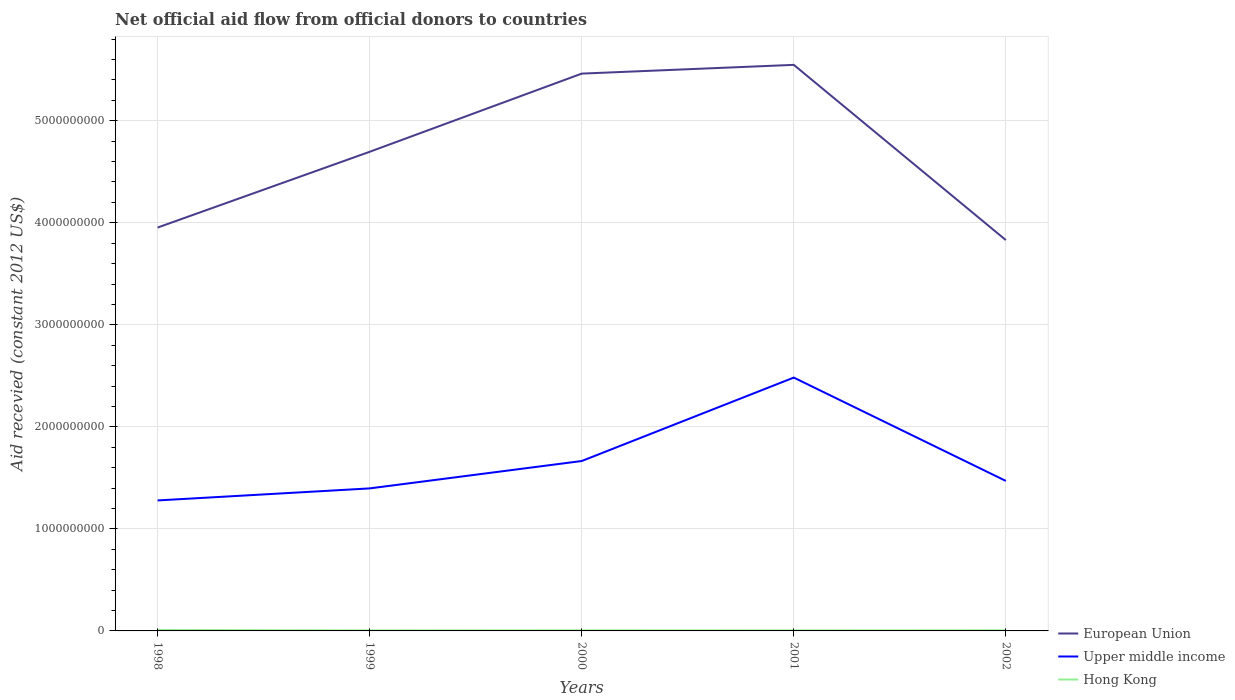Across all years, what is the maximum total aid received in Hong Kong?
Offer a terse response. 4.73e+06. What is the total total aid received in European Union in the graph?
Give a very brief answer. 1.23e+08. What is the difference between the highest and the second highest total aid received in European Union?
Provide a short and direct response. 1.72e+09. What is the difference between the highest and the lowest total aid received in Upper middle income?
Your response must be concise. 2. How many years are there in the graph?
Give a very brief answer. 5. What is the difference between two consecutive major ticks on the Y-axis?
Provide a short and direct response. 1.00e+09. Does the graph contain grids?
Your answer should be very brief. Yes. What is the title of the graph?
Keep it short and to the point. Net official aid flow from official donors to countries. What is the label or title of the X-axis?
Your answer should be compact. Years. What is the label or title of the Y-axis?
Ensure brevity in your answer.  Aid recevied (constant 2012 US$). What is the Aid recevied (constant 2012 US$) in European Union in 1998?
Provide a succinct answer. 3.95e+09. What is the Aid recevied (constant 2012 US$) in Upper middle income in 1998?
Provide a short and direct response. 1.28e+09. What is the Aid recevied (constant 2012 US$) in Hong Kong in 1998?
Provide a short and direct response. 9.64e+06. What is the Aid recevied (constant 2012 US$) of European Union in 1999?
Ensure brevity in your answer.  4.70e+09. What is the Aid recevied (constant 2012 US$) of Upper middle income in 1999?
Keep it short and to the point. 1.40e+09. What is the Aid recevied (constant 2012 US$) in Hong Kong in 1999?
Your answer should be very brief. 4.73e+06. What is the Aid recevied (constant 2012 US$) in European Union in 2000?
Ensure brevity in your answer.  5.46e+09. What is the Aid recevied (constant 2012 US$) of Upper middle income in 2000?
Your response must be concise. 1.67e+09. What is the Aid recevied (constant 2012 US$) in Hong Kong in 2000?
Offer a very short reply. 5.83e+06. What is the Aid recevied (constant 2012 US$) in European Union in 2001?
Make the answer very short. 5.55e+09. What is the Aid recevied (constant 2012 US$) in Upper middle income in 2001?
Ensure brevity in your answer.  2.48e+09. What is the Aid recevied (constant 2012 US$) in Hong Kong in 2001?
Give a very brief answer. 5.12e+06. What is the Aid recevied (constant 2012 US$) in European Union in 2002?
Provide a succinct answer. 3.83e+09. What is the Aid recevied (constant 2012 US$) in Upper middle income in 2002?
Your answer should be very brief. 1.47e+09. What is the Aid recevied (constant 2012 US$) of Hong Kong in 2002?
Provide a succinct answer. 5.92e+06. Across all years, what is the maximum Aid recevied (constant 2012 US$) of European Union?
Provide a succinct answer. 5.55e+09. Across all years, what is the maximum Aid recevied (constant 2012 US$) in Upper middle income?
Offer a very short reply. 2.48e+09. Across all years, what is the maximum Aid recevied (constant 2012 US$) in Hong Kong?
Keep it short and to the point. 9.64e+06. Across all years, what is the minimum Aid recevied (constant 2012 US$) of European Union?
Your answer should be very brief. 3.83e+09. Across all years, what is the minimum Aid recevied (constant 2012 US$) in Upper middle income?
Your answer should be very brief. 1.28e+09. Across all years, what is the minimum Aid recevied (constant 2012 US$) of Hong Kong?
Keep it short and to the point. 4.73e+06. What is the total Aid recevied (constant 2012 US$) in European Union in the graph?
Your answer should be compact. 2.35e+1. What is the total Aid recevied (constant 2012 US$) of Upper middle income in the graph?
Provide a short and direct response. 8.29e+09. What is the total Aid recevied (constant 2012 US$) of Hong Kong in the graph?
Offer a terse response. 3.12e+07. What is the difference between the Aid recevied (constant 2012 US$) of European Union in 1998 and that in 1999?
Your response must be concise. -7.42e+08. What is the difference between the Aid recevied (constant 2012 US$) in Upper middle income in 1998 and that in 1999?
Your response must be concise. -1.18e+08. What is the difference between the Aid recevied (constant 2012 US$) of Hong Kong in 1998 and that in 1999?
Offer a terse response. 4.91e+06. What is the difference between the Aid recevied (constant 2012 US$) in European Union in 1998 and that in 2000?
Ensure brevity in your answer.  -1.51e+09. What is the difference between the Aid recevied (constant 2012 US$) in Upper middle income in 1998 and that in 2000?
Ensure brevity in your answer.  -3.86e+08. What is the difference between the Aid recevied (constant 2012 US$) of Hong Kong in 1998 and that in 2000?
Keep it short and to the point. 3.81e+06. What is the difference between the Aid recevied (constant 2012 US$) in European Union in 1998 and that in 2001?
Your answer should be compact. -1.59e+09. What is the difference between the Aid recevied (constant 2012 US$) in Upper middle income in 1998 and that in 2001?
Provide a short and direct response. -1.20e+09. What is the difference between the Aid recevied (constant 2012 US$) of Hong Kong in 1998 and that in 2001?
Your answer should be compact. 4.52e+06. What is the difference between the Aid recevied (constant 2012 US$) in European Union in 1998 and that in 2002?
Offer a terse response. 1.23e+08. What is the difference between the Aid recevied (constant 2012 US$) in Upper middle income in 1998 and that in 2002?
Your answer should be compact. -1.91e+08. What is the difference between the Aid recevied (constant 2012 US$) in Hong Kong in 1998 and that in 2002?
Ensure brevity in your answer.  3.72e+06. What is the difference between the Aid recevied (constant 2012 US$) in European Union in 1999 and that in 2000?
Provide a short and direct response. -7.66e+08. What is the difference between the Aid recevied (constant 2012 US$) of Upper middle income in 1999 and that in 2000?
Ensure brevity in your answer.  -2.68e+08. What is the difference between the Aid recevied (constant 2012 US$) in Hong Kong in 1999 and that in 2000?
Your answer should be very brief. -1.10e+06. What is the difference between the Aid recevied (constant 2012 US$) of European Union in 1999 and that in 2001?
Provide a succinct answer. -8.52e+08. What is the difference between the Aid recevied (constant 2012 US$) in Upper middle income in 1999 and that in 2001?
Your answer should be compact. -1.09e+09. What is the difference between the Aid recevied (constant 2012 US$) in Hong Kong in 1999 and that in 2001?
Give a very brief answer. -3.90e+05. What is the difference between the Aid recevied (constant 2012 US$) in European Union in 1999 and that in 2002?
Your answer should be compact. 8.65e+08. What is the difference between the Aid recevied (constant 2012 US$) of Upper middle income in 1999 and that in 2002?
Provide a succinct answer. -7.33e+07. What is the difference between the Aid recevied (constant 2012 US$) of Hong Kong in 1999 and that in 2002?
Your response must be concise. -1.19e+06. What is the difference between the Aid recevied (constant 2012 US$) in European Union in 2000 and that in 2001?
Provide a succinct answer. -8.58e+07. What is the difference between the Aid recevied (constant 2012 US$) of Upper middle income in 2000 and that in 2001?
Give a very brief answer. -8.18e+08. What is the difference between the Aid recevied (constant 2012 US$) in Hong Kong in 2000 and that in 2001?
Make the answer very short. 7.10e+05. What is the difference between the Aid recevied (constant 2012 US$) in European Union in 2000 and that in 2002?
Make the answer very short. 1.63e+09. What is the difference between the Aid recevied (constant 2012 US$) of Upper middle income in 2000 and that in 2002?
Offer a terse response. 1.95e+08. What is the difference between the Aid recevied (constant 2012 US$) in European Union in 2001 and that in 2002?
Provide a succinct answer. 1.72e+09. What is the difference between the Aid recevied (constant 2012 US$) of Upper middle income in 2001 and that in 2002?
Keep it short and to the point. 1.01e+09. What is the difference between the Aid recevied (constant 2012 US$) of Hong Kong in 2001 and that in 2002?
Your answer should be very brief. -8.00e+05. What is the difference between the Aid recevied (constant 2012 US$) in European Union in 1998 and the Aid recevied (constant 2012 US$) in Upper middle income in 1999?
Your answer should be very brief. 2.56e+09. What is the difference between the Aid recevied (constant 2012 US$) in European Union in 1998 and the Aid recevied (constant 2012 US$) in Hong Kong in 1999?
Ensure brevity in your answer.  3.95e+09. What is the difference between the Aid recevied (constant 2012 US$) of Upper middle income in 1998 and the Aid recevied (constant 2012 US$) of Hong Kong in 1999?
Ensure brevity in your answer.  1.27e+09. What is the difference between the Aid recevied (constant 2012 US$) of European Union in 1998 and the Aid recevied (constant 2012 US$) of Upper middle income in 2000?
Keep it short and to the point. 2.29e+09. What is the difference between the Aid recevied (constant 2012 US$) of European Union in 1998 and the Aid recevied (constant 2012 US$) of Hong Kong in 2000?
Your response must be concise. 3.95e+09. What is the difference between the Aid recevied (constant 2012 US$) in Upper middle income in 1998 and the Aid recevied (constant 2012 US$) in Hong Kong in 2000?
Provide a succinct answer. 1.27e+09. What is the difference between the Aid recevied (constant 2012 US$) in European Union in 1998 and the Aid recevied (constant 2012 US$) in Upper middle income in 2001?
Provide a succinct answer. 1.47e+09. What is the difference between the Aid recevied (constant 2012 US$) in European Union in 1998 and the Aid recevied (constant 2012 US$) in Hong Kong in 2001?
Your answer should be very brief. 3.95e+09. What is the difference between the Aid recevied (constant 2012 US$) of Upper middle income in 1998 and the Aid recevied (constant 2012 US$) of Hong Kong in 2001?
Your answer should be compact. 1.27e+09. What is the difference between the Aid recevied (constant 2012 US$) of European Union in 1998 and the Aid recevied (constant 2012 US$) of Upper middle income in 2002?
Offer a terse response. 2.48e+09. What is the difference between the Aid recevied (constant 2012 US$) in European Union in 1998 and the Aid recevied (constant 2012 US$) in Hong Kong in 2002?
Ensure brevity in your answer.  3.95e+09. What is the difference between the Aid recevied (constant 2012 US$) in Upper middle income in 1998 and the Aid recevied (constant 2012 US$) in Hong Kong in 2002?
Provide a succinct answer. 1.27e+09. What is the difference between the Aid recevied (constant 2012 US$) in European Union in 1999 and the Aid recevied (constant 2012 US$) in Upper middle income in 2000?
Your response must be concise. 3.03e+09. What is the difference between the Aid recevied (constant 2012 US$) in European Union in 1999 and the Aid recevied (constant 2012 US$) in Hong Kong in 2000?
Offer a very short reply. 4.69e+09. What is the difference between the Aid recevied (constant 2012 US$) in Upper middle income in 1999 and the Aid recevied (constant 2012 US$) in Hong Kong in 2000?
Provide a succinct answer. 1.39e+09. What is the difference between the Aid recevied (constant 2012 US$) of European Union in 1999 and the Aid recevied (constant 2012 US$) of Upper middle income in 2001?
Your answer should be very brief. 2.21e+09. What is the difference between the Aid recevied (constant 2012 US$) of European Union in 1999 and the Aid recevied (constant 2012 US$) of Hong Kong in 2001?
Your answer should be compact. 4.69e+09. What is the difference between the Aid recevied (constant 2012 US$) of Upper middle income in 1999 and the Aid recevied (constant 2012 US$) of Hong Kong in 2001?
Keep it short and to the point. 1.39e+09. What is the difference between the Aid recevied (constant 2012 US$) of European Union in 1999 and the Aid recevied (constant 2012 US$) of Upper middle income in 2002?
Provide a short and direct response. 3.23e+09. What is the difference between the Aid recevied (constant 2012 US$) in European Union in 1999 and the Aid recevied (constant 2012 US$) in Hong Kong in 2002?
Make the answer very short. 4.69e+09. What is the difference between the Aid recevied (constant 2012 US$) in Upper middle income in 1999 and the Aid recevied (constant 2012 US$) in Hong Kong in 2002?
Keep it short and to the point. 1.39e+09. What is the difference between the Aid recevied (constant 2012 US$) in European Union in 2000 and the Aid recevied (constant 2012 US$) in Upper middle income in 2001?
Offer a very short reply. 2.98e+09. What is the difference between the Aid recevied (constant 2012 US$) in European Union in 2000 and the Aid recevied (constant 2012 US$) in Hong Kong in 2001?
Make the answer very short. 5.46e+09. What is the difference between the Aid recevied (constant 2012 US$) in Upper middle income in 2000 and the Aid recevied (constant 2012 US$) in Hong Kong in 2001?
Your response must be concise. 1.66e+09. What is the difference between the Aid recevied (constant 2012 US$) of European Union in 2000 and the Aid recevied (constant 2012 US$) of Upper middle income in 2002?
Provide a short and direct response. 3.99e+09. What is the difference between the Aid recevied (constant 2012 US$) in European Union in 2000 and the Aid recevied (constant 2012 US$) in Hong Kong in 2002?
Ensure brevity in your answer.  5.46e+09. What is the difference between the Aid recevied (constant 2012 US$) of Upper middle income in 2000 and the Aid recevied (constant 2012 US$) of Hong Kong in 2002?
Your response must be concise. 1.66e+09. What is the difference between the Aid recevied (constant 2012 US$) in European Union in 2001 and the Aid recevied (constant 2012 US$) in Upper middle income in 2002?
Your response must be concise. 4.08e+09. What is the difference between the Aid recevied (constant 2012 US$) of European Union in 2001 and the Aid recevied (constant 2012 US$) of Hong Kong in 2002?
Ensure brevity in your answer.  5.54e+09. What is the difference between the Aid recevied (constant 2012 US$) in Upper middle income in 2001 and the Aid recevied (constant 2012 US$) in Hong Kong in 2002?
Provide a short and direct response. 2.48e+09. What is the average Aid recevied (constant 2012 US$) of European Union per year?
Your answer should be very brief. 4.70e+09. What is the average Aid recevied (constant 2012 US$) in Upper middle income per year?
Your answer should be compact. 1.66e+09. What is the average Aid recevied (constant 2012 US$) in Hong Kong per year?
Your answer should be compact. 6.25e+06. In the year 1998, what is the difference between the Aid recevied (constant 2012 US$) in European Union and Aid recevied (constant 2012 US$) in Upper middle income?
Your response must be concise. 2.67e+09. In the year 1998, what is the difference between the Aid recevied (constant 2012 US$) in European Union and Aid recevied (constant 2012 US$) in Hong Kong?
Make the answer very short. 3.94e+09. In the year 1998, what is the difference between the Aid recevied (constant 2012 US$) in Upper middle income and Aid recevied (constant 2012 US$) in Hong Kong?
Your answer should be compact. 1.27e+09. In the year 1999, what is the difference between the Aid recevied (constant 2012 US$) of European Union and Aid recevied (constant 2012 US$) of Upper middle income?
Give a very brief answer. 3.30e+09. In the year 1999, what is the difference between the Aid recevied (constant 2012 US$) in European Union and Aid recevied (constant 2012 US$) in Hong Kong?
Keep it short and to the point. 4.69e+09. In the year 1999, what is the difference between the Aid recevied (constant 2012 US$) in Upper middle income and Aid recevied (constant 2012 US$) in Hong Kong?
Provide a short and direct response. 1.39e+09. In the year 2000, what is the difference between the Aid recevied (constant 2012 US$) in European Union and Aid recevied (constant 2012 US$) in Upper middle income?
Provide a short and direct response. 3.80e+09. In the year 2000, what is the difference between the Aid recevied (constant 2012 US$) in European Union and Aid recevied (constant 2012 US$) in Hong Kong?
Ensure brevity in your answer.  5.46e+09. In the year 2000, what is the difference between the Aid recevied (constant 2012 US$) in Upper middle income and Aid recevied (constant 2012 US$) in Hong Kong?
Ensure brevity in your answer.  1.66e+09. In the year 2001, what is the difference between the Aid recevied (constant 2012 US$) in European Union and Aid recevied (constant 2012 US$) in Upper middle income?
Offer a very short reply. 3.07e+09. In the year 2001, what is the difference between the Aid recevied (constant 2012 US$) in European Union and Aid recevied (constant 2012 US$) in Hong Kong?
Provide a short and direct response. 5.54e+09. In the year 2001, what is the difference between the Aid recevied (constant 2012 US$) of Upper middle income and Aid recevied (constant 2012 US$) of Hong Kong?
Your response must be concise. 2.48e+09. In the year 2002, what is the difference between the Aid recevied (constant 2012 US$) in European Union and Aid recevied (constant 2012 US$) in Upper middle income?
Offer a very short reply. 2.36e+09. In the year 2002, what is the difference between the Aid recevied (constant 2012 US$) of European Union and Aid recevied (constant 2012 US$) of Hong Kong?
Provide a short and direct response. 3.82e+09. In the year 2002, what is the difference between the Aid recevied (constant 2012 US$) of Upper middle income and Aid recevied (constant 2012 US$) of Hong Kong?
Provide a short and direct response. 1.46e+09. What is the ratio of the Aid recevied (constant 2012 US$) in European Union in 1998 to that in 1999?
Your answer should be compact. 0.84. What is the ratio of the Aid recevied (constant 2012 US$) of Upper middle income in 1998 to that in 1999?
Keep it short and to the point. 0.92. What is the ratio of the Aid recevied (constant 2012 US$) of Hong Kong in 1998 to that in 1999?
Make the answer very short. 2.04. What is the ratio of the Aid recevied (constant 2012 US$) in European Union in 1998 to that in 2000?
Provide a succinct answer. 0.72. What is the ratio of the Aid recevied (constant 2012 US$) in Upper middle income in 1998 to that in 2000?
Provide a succinct answer. 0.77. What is the ratio of the Aid recevied (constant 2012 US$) in Hong Kong in 1998 to that in 2000?
Ensure brevity in your answer.  1.65. What is the ratio of the Aid recevied (constant 2012 US$) in European Union in 1998 to that in 2001?
Your response must be concise. 0.71. What is the ratio of the Aid recevied (constant 2012 US$) in Upper middle income in 1998 to that in 2001?
Your answer should be very brief. 0.52. What is the ratio of the Aid recevied (constant 2012 US$) in Hong Kong in 1998 to that in 2001?
Your response must be concise. 1.88. What is the ratio of the Aid recevied (constant 2012 US$) of European Union in 1998 to that in 2002?
Keep it short and to the point. 1.03. What is the ratio of the Aid recevied (constant 2012 US$) in Upper middle income in 1998 to that in 2002?
Your answer should be very brief. 0.87. What is the ratio of the Aid recevied (constant 2012 US$) of Hong Kong in 1998 to that in 2002?
Give a very brief answer. 1.63. What is the ratio of the Aid recevied (constant 2012 US$) in European Union in 1999 to that in 2000?
Keep it short and to the point. 0.86. What is the ratio of the Aid recevied (constant 2012 US$) of Upper middle income in 1999 to that in 2000?
Offer a very short reply. 0.84. What is the ratio of the Aid recevied (constant 2012 US$) in Hong Kong in 1999 to that in 2000?
Ensure brevity in your answer.  0.81. What is the ratio of the Aid recevied (constant 2012 US$) in European Union in 1999 to that in 2001?
Provide a succinct answer. 0.85. What is the ratio of the Aid recevied (constant 2012 US$) of Upper middle income in 1999 to that in 2001?
Offer a very short reply. 0.56. What is the ratio of the Aid recevied (constant 2012 US$) of Hong Kong in 1999 to that in 2001?
Ensure brevity in your answer.  0.92. What is the ratio of the Aid recevied (constant 2012 US$) in European Union in 1999 to that in 2002?
Your response must be concise. 1.23. What is the ratio of the Aid recevied (constant 2012 US$) in Upper middle income in 1999 to that in 2002?
Provide a succinct answer. 0.95. What is the ratio of the Aid recevied (constant 2012 US$) of Hong Kong in 1999 to that in 2002?
Offer a very short reply. 0.8. What is the ratio of the Aid recevied (constant 2012 US$) of European Union in 2000 to that in 2001?
Make the answer very short. 0.98. What is the ratio of the Aid recevied (constant 2012 US$) in Upper middle income in 2000 to that in 2001?
Ensure brevity in your answer.  0.67. What is the ratio of the Aid recevied (constant 2012 US$) of Hong Kong in 2000 to that in 2001?
Offer a terse response. 1.14. What is the ratio of the Aid recevied (constant 2012 US$) of European Union in 2000 to that in 2002?
Make the answer very short. 1.43. What is the ratio of the Aid recevied (constant 2012 US$) of Upper middle income in 2000 to that in 2002?
Make the answer very short. 1.13. What is the ratio of the Aid recevied (constant 2012 US$) of European Union in 2001 to that in 2002?
Make the answer very short. 1.45. What is the ratio of the Aid recevied (constant 2012 US$) of Upper middle income in 2001 to that in 2002?
Ensure brevity in your answer.  1.69. What is the ratio of the Aid recevied (constant 2012 US$) in Hong Kong in 2001 to that in 2002?
Your answer should be very brief. 0.86. What is the difference between the highest and the second highest Aid recevied (constant 2012 US$) of European Union?
Ensure brevity in your answer.  8.58e+07. What is the difference between the highest and the second highest Aid recevied (constant 2012 US$) in Upper middle income?
Your response must be concise. 8.18e+08. What is the difference between the highest and the second highest Aid recevied (constant 2012 US$) of Hong Kong?
Make the answer very short. 3.72e+06. What is the difference between the highest and the lowest Aid recevied (constant 2012 US$) of European Union?
Ensure brevity in your answer.  1.72e+09. What is the difference between the highest and the lowest Aid recevied (constant 2012 US$) in Upper middle income?
Keep it short and to the point. 1.20e+09. What is the difference between the highest and the lowest Aid recevied (constant 2012 US$) in Hong Kong?
Provide a succinct answer. 4.91e+06. 